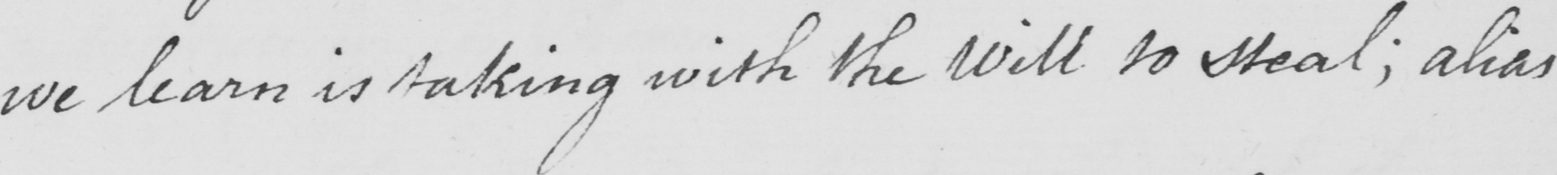What text is written in this handwritten line? we learn is taking with the will to steal ; alias 